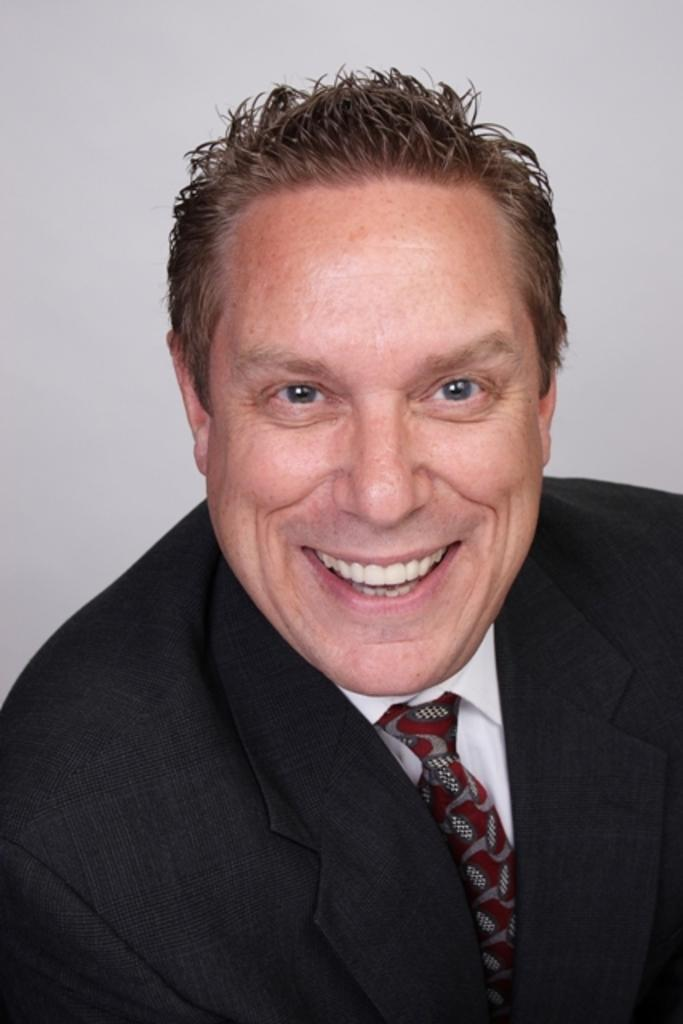Who is present in the image? There is a man in the picture. What expression does the man have? The man is smiling. Can you describe the background of the image? The background of the image is plain. What type of plough is the man using in the image? There is no plough present in the image; it features a man who is smiling. What loss has the man experienced in the image? There is no indication of any loss in the image; it simply shows a man who is smiling. 